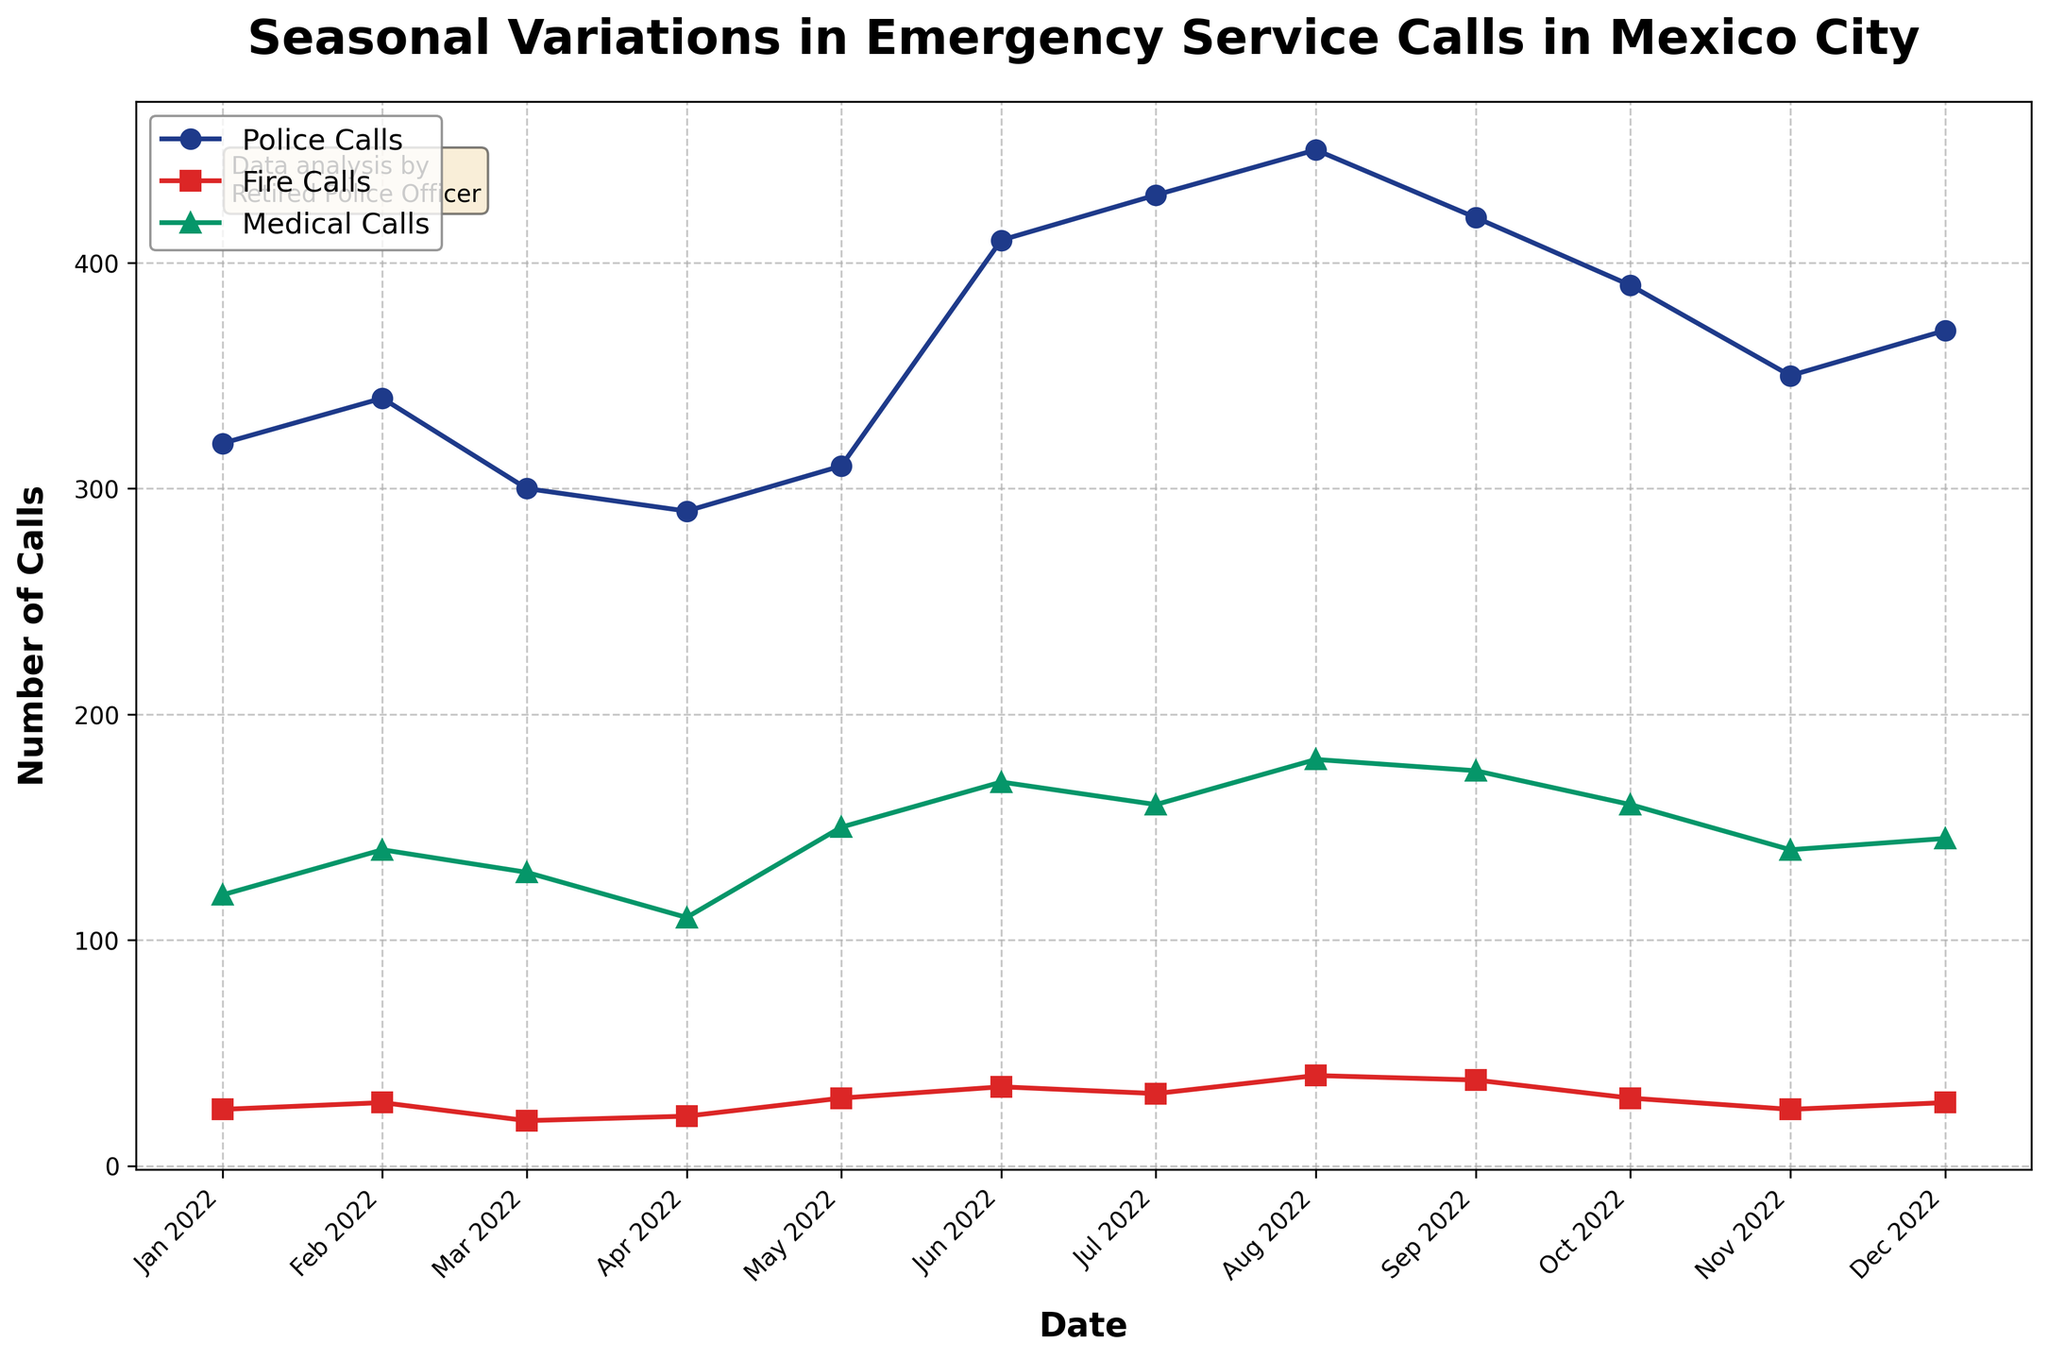What is the title of the figure? The title is prominently displayed at the top of the figure. It provides a clear indication of what the plot is about.
Answer: Seasonal Variations in Emergency Service Calls in Mexico City How many emergency service call categories are tracked in the figure? By looking at the legend or the lines with different markers and colors, we can count the distinct categories being represented.
Answer: 3 Which month had the highest number of police calls? By inspecting the blue line (Police Calls) for its peak value along the timeline, we can find the month corresponding to the highest point.
Answer: August 2022 How do the number of fire calls in June compare to those in December? Look at the red squares on the line graph for June and December, and compare their values.
Answer: June had more fire calls than December What is the difference in medical calls between the month with the highest and the month with the lowest calls? Identify the highest and lowest points on the green line (Medical Calls), then subtract the lowest value from the highest value.
Answer: 70 What trends do you observe in police calls from January to August 2022? Analyze the blue line from January to August to see if it is generally increasing, decreasing, or fluctuating.
Answer: Increasing trend In which months do the number of fire calls and medical calls both increase compared to their previous month? Look for consecutive months where both the red and green lines increase compared to the previous month.
Answer: February and August What is the total number of calls for all categories in October? Sum the values of Police Calls, Fire Calls, and Medical Calls for the month of October.
Answer: 580 Which category has the most significant seasonal variation? Compare the ranges (highest value - lowest value) of all three categories to determine the most considerable difference in values.
Answer: Police Calls What trend do you observe for fire calls throughout the year? Analyze the overall direction of the red line (Fire Calls) over the 12 months to determine if it's rising, falling, or maintaining.
Answer: Fluctuating but generally increasing 